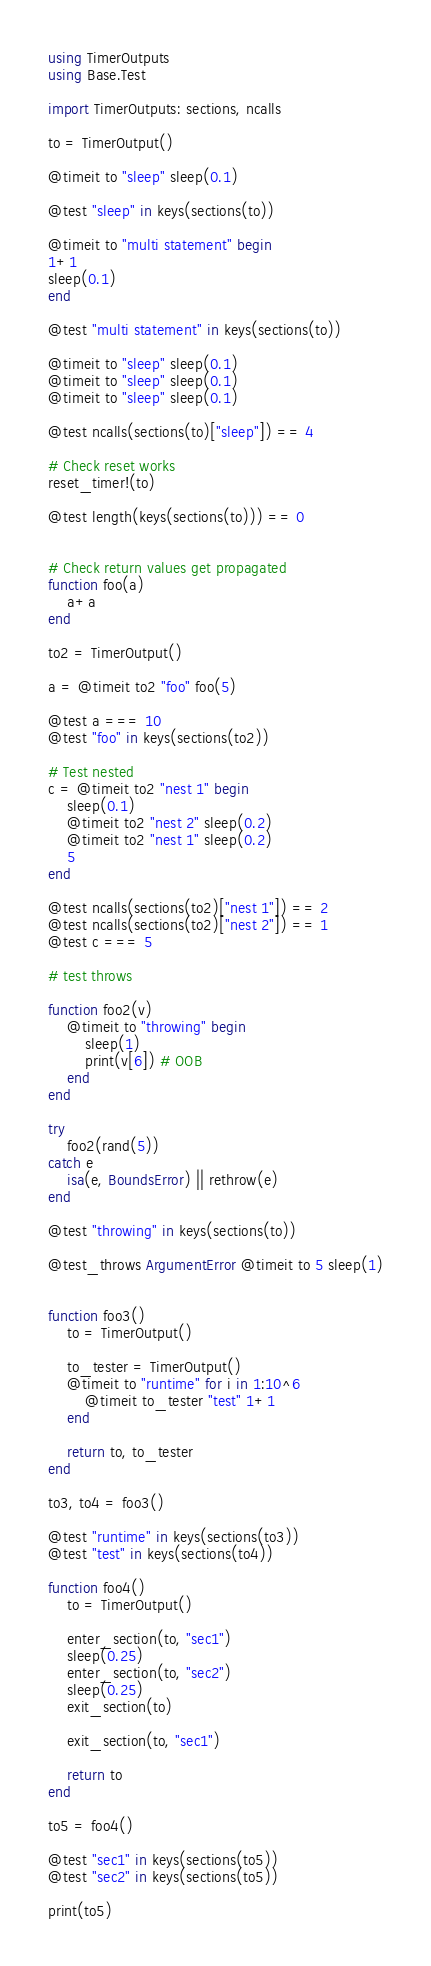Convert code to text. <code><loc_0><loc_0><loc_500><loc_500><_Julia_>using TimerOutputs
using Base.Test

import TimerOutputs: sections, ncalls

to = TimerOutput()

@timeit to "sleep" sleep(0.1)

@test "sleep" in keys(sections(to))

@timeit to "multi statement" begin
1+1
sleep(0.1)
end

@test "multi statement" in keys(sections(to))

@timeit to "sleep" sleep(0.1)
@timeit to "sleep" sleep(0.1)
@timeit to "sleep" sleep(0.1)

@test ncalls(sections(to)["sleep"]) == 4

# Check reset works
reset_timer!(to)

@test length(keys(sections(to))) == 0


# Check return values get propagated
function foo(a)
    a+a
end

to2 = TimerOutput()

a = @timeit to2 "foo" foo(5)

@test a === 10
@test "foo" in keys(sections(to2))

# Test nested
c = @timeit to2 "nest 1" begin
    sleep(0.1)
    @timeit to2 "nest 2" sleep(0.2)
    @timeit to2 "nest 1" sleep(0.2)
    5
end

@test ncalls(sections(to2)["nest 1"]) == 2
@test ncalls(sections(to2)["nest 2"]) == 1
@test c === 5

# test throws

function foo2(v)
    @timeit to "throwing" begin
        sleep(1)
        print(v[6]) # OOB
    end
end

try
    foo2(rand(5))
catch e
    isa(e, BoundsError) || rethrow(e)
end

@test "throwing" in keys(sections(to))

@test_throws ArgumentError @timeit to 5 sleep(1)


function foo3()
    to = TimerOutput()

    to_tester = TimerOutput()
    @timeit to "runtime" for i in 1:10^6
        @timeit to_tester "test" 1+1
    end

    return to, to_tester
end

to3, to4 = foo3()

@test "runtime" in keys(sections(to3))
@test "test" in keys(sections(to4))

function foo4()
    to = TimerOutput()

    enter_section(to, "sec1")
    sleep(0.25)
    enter_section(to, "sec2")
    sleep(0.25)
    exit_section(to)

    exit_section(to, "sec1")

    return to
end

to5 = foo4()

@test "sec1" in keys(sections(to5))
@test "sec2" in keys(sections(to5))

print(to5)
</code> 